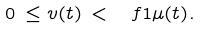Convert formula to latex. <formula><loc_0><loc_0><loc_500><loc_500>0 \, \leq v ( t ) \, < \, \ f { 1 } { \mu ( t ) } .</formula> 